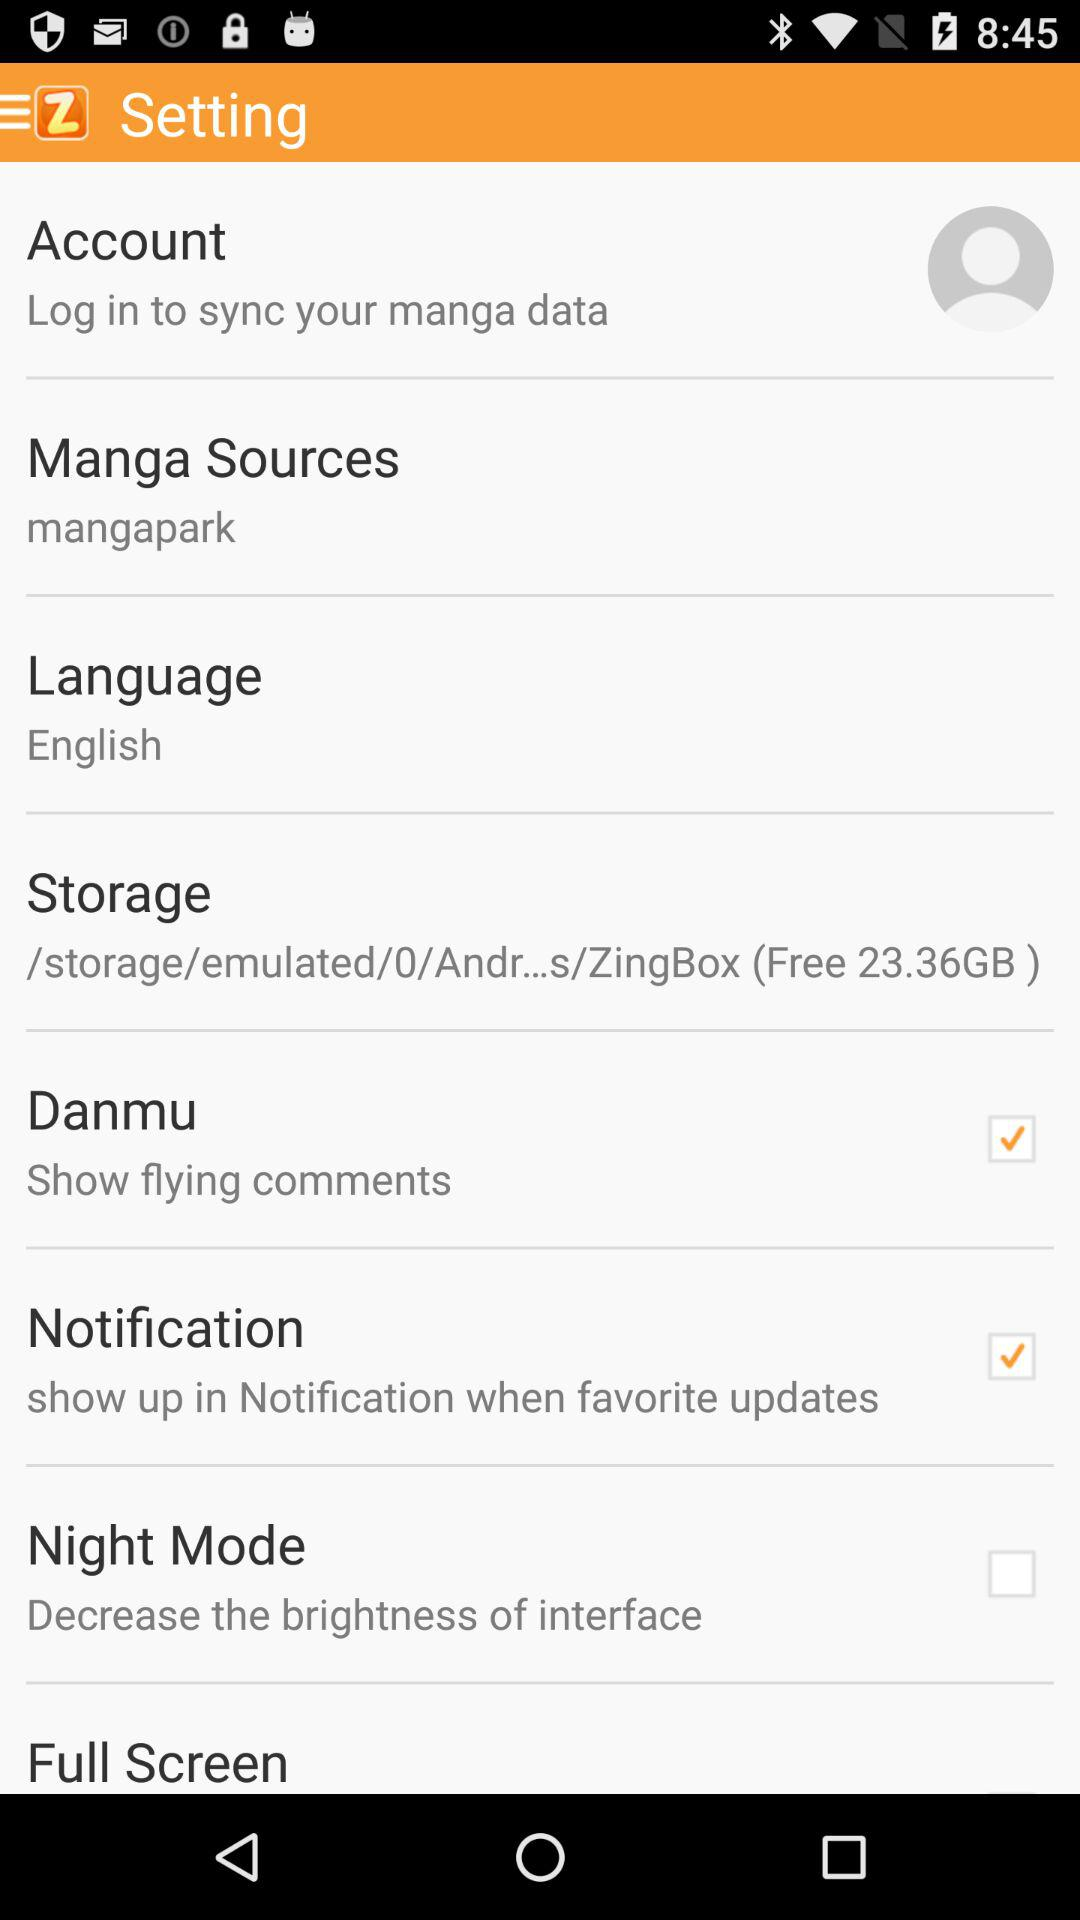What's the language? The language is English. 